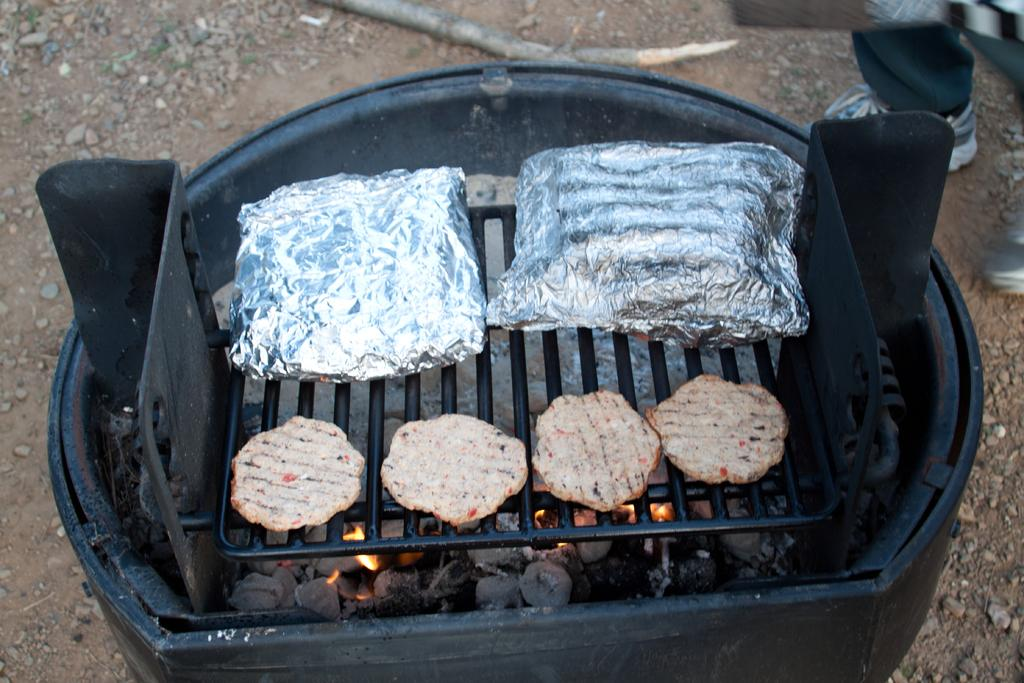What type of food items can be seen in the image? There are food items in the image, but their specific type is not mentioned. What is covering the food items in the image? There are silver foils in the image, which are covering the food items. Where are the food items and silver foils placed? The food items and silver foils are kept on a grill. What is used to cook the food items in the image? There are coals in the image, and they are fired, which suggests they are used for cooking. What is the color of the object in the image? There is a black color thing in the image, but its specific object is not mentioned. How many nails are used to hold the sugar in the image? There is no sugar or nails present in the image. What type of nail is used to hold the sugar in the image? There is no sugar or nail present in the image, so it is not possible to answer that question. 